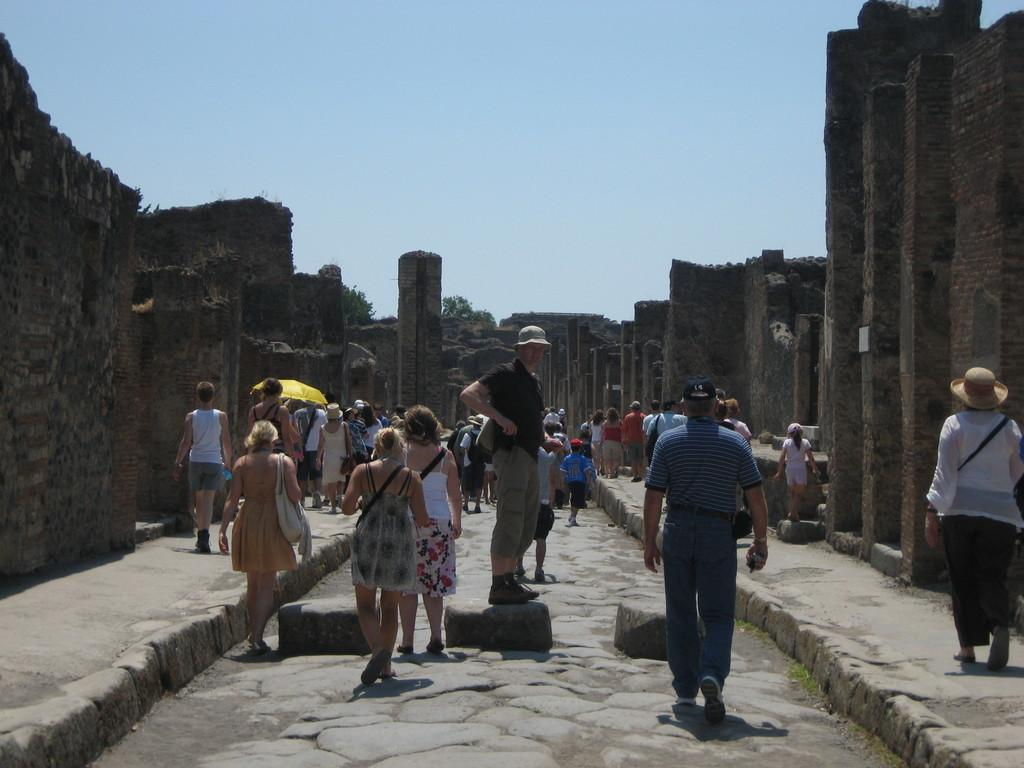What are the persons in the image doing? The persons in the image are walking and standing. Where are the persons located in the image? The persons are on the floor. What can be seen on both sides of the image? There are walls on both sides of the image. What is visible at the top of the image? The sky is visible at the top of the image. What type of marble is being used to decorate the roof in the image? There is no marble or roof present in the image; it features persons walking and standing on the floor with walls on both sides and the sky visible at the top. 